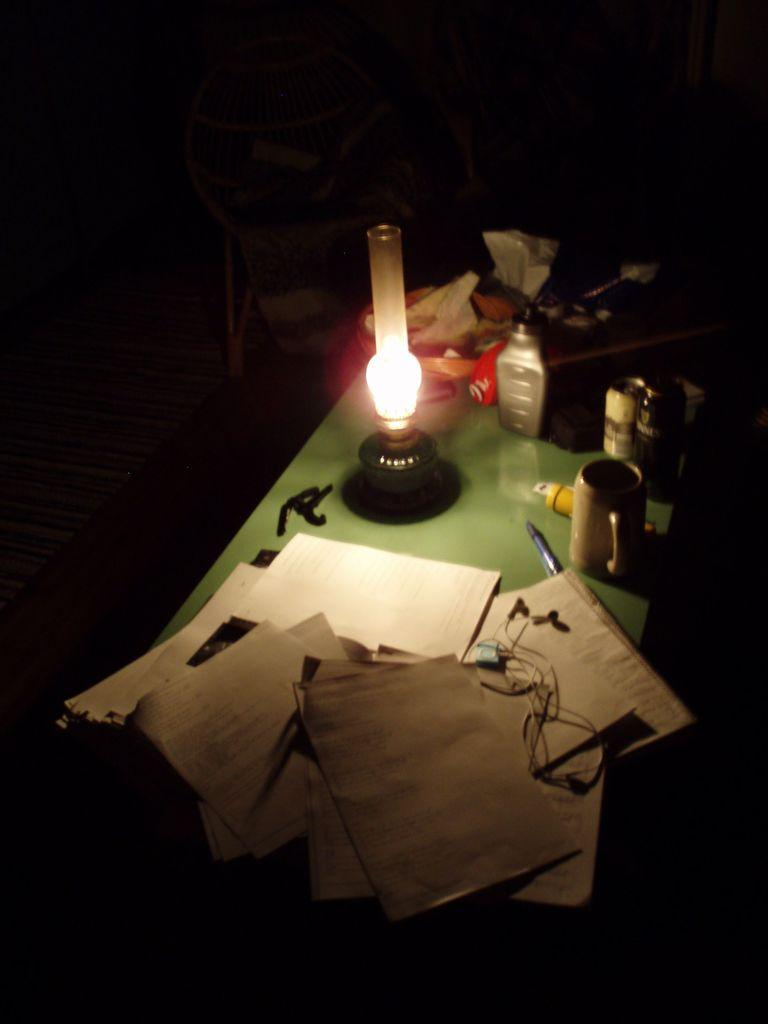What color is the table in the image? The table in the image is green. What object is on the table that provides light? There is a lamp on the table. What type of items can be seen on the table related to work or study? Papers, a pen, and accessories are visible on the table. What is used for listening to audio on the table? Earphones are present on the table. What type of beverage container is on the table? There is a mug on the table. What is the overall lighting condition in the image? The background of the image is dark. Can you describe the kitten's reaction to the steam coming from the mug in the image? There is no kitten or steam present in the image. 